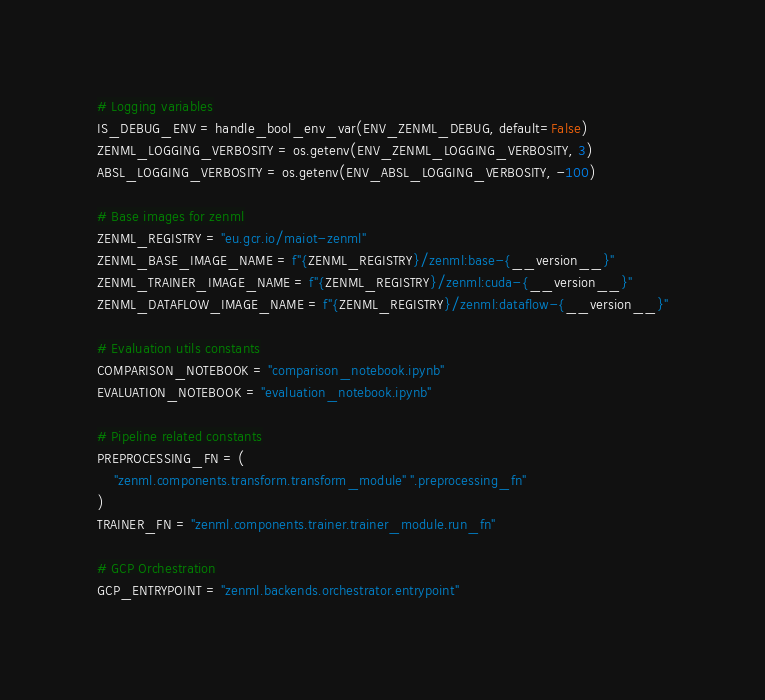Convert code to text. <code><loc_0><loc_0><loc_500><loc_500><_Python_>
# Logging variables
IS_DEBUG_ENV = handle_bool_env_var(ENV_ZENML_DEBUG, default=False)
ZENML_LOGGING_VERBOSITY = os.getenv(ENV_ZENML_LOGGING_VERBOSITY, 3)
ABSL_LOGGING_VERBOSITY = os.getenv(ENV_ABSL_LOGGING_VERBOSITY, -100)

# Base images for zenml
ZENML_REGISTRY = "eu.gcr.io/maiot-zenml"
ZENML_BASE_IMAGE_NAME = f"{ZENML_REGISTRY}/zenml:base-{__version__}"
ZENML_TRAINER_IMAGE_NAME = f"{ZENML_REGISTRY}/zenml:cuda-{__version__}"
ZENML_DATAFLOW_IMAGE_NAME = f"{ZENML_REGISTRY}/zenml:dataflow-{__version__}"

# Evaluation utils constants
COMPARISON_NOTEBOOK = "comparison_notebook.ipynb"
EVALUATION_NOTEBOOK = "evaluation_notebook.ipynb"

# Pipeline related constants
PREPROCESSING_FN = (
    "zenml.components.transform.transform_module" ".preprocessing_fn"
)
TRAINER_FN = "zenml.components.trainer.trainer_module.run_fn"

# GCP Orchestration
GCP_ENTRYPOINT = "zenml.backends.orchestrator.entrypoint"</code> 